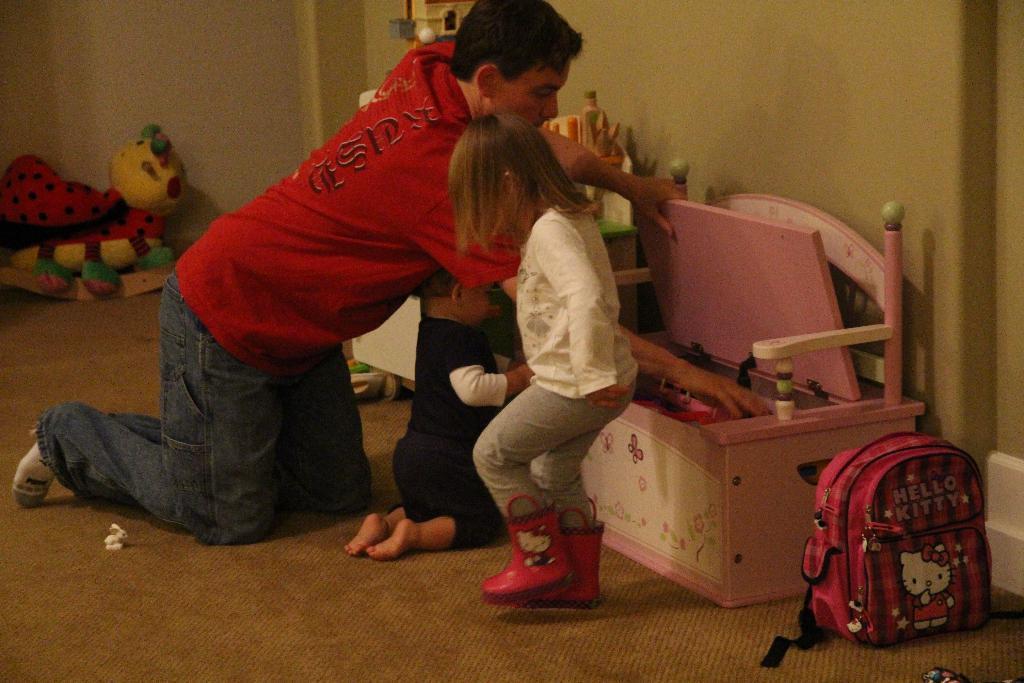Please provide a concise description of this image. In this image I can see a person wearing red t shirt and jeans and two other children wearing black, white and grey colored dress are on the floor. I can see a pink colored box with few objects in it, a pink colored bag and a toy which is red, blue, black and cream in color on the floor. In the background I can see the wall. 